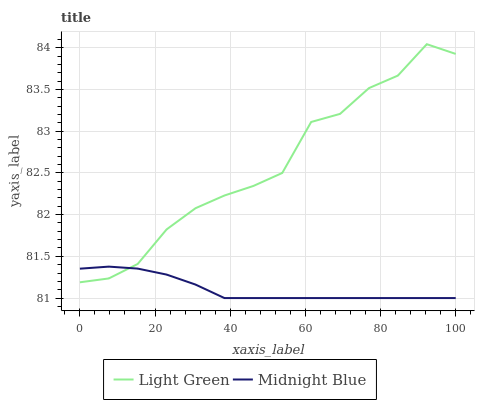Does Midnight Blue have the minimum area under the curve?
Answer yes or no. Yes. Does Light Green have the maximum area under the curve?
Answer yes or no. Yes. Does Light Green have the minimum area under the curve?
Answer yes or no. No. Is Midnight Blue the smoothest?
Answer yes or no. Yes. Is Light Green the roughest?
Answer yes or no. Yes. Is Light Green the smoothest?
Answer yes or no. No. Does Midnight Blue have the lowest value?
Answer yes or no. Yes. Does Light Green have the lowest value?
Answer yes or no. No. Does Light Green have the highest value?
Answer yes or no. Yes. Does Midnight Blue intersect Light Green?
Answer yes or no. Yes. Is Midnight Blue less than Light Green?
Answer yes or no. No. Is Midnight Blue greater than Light Green?
Answer yes or no. No. 